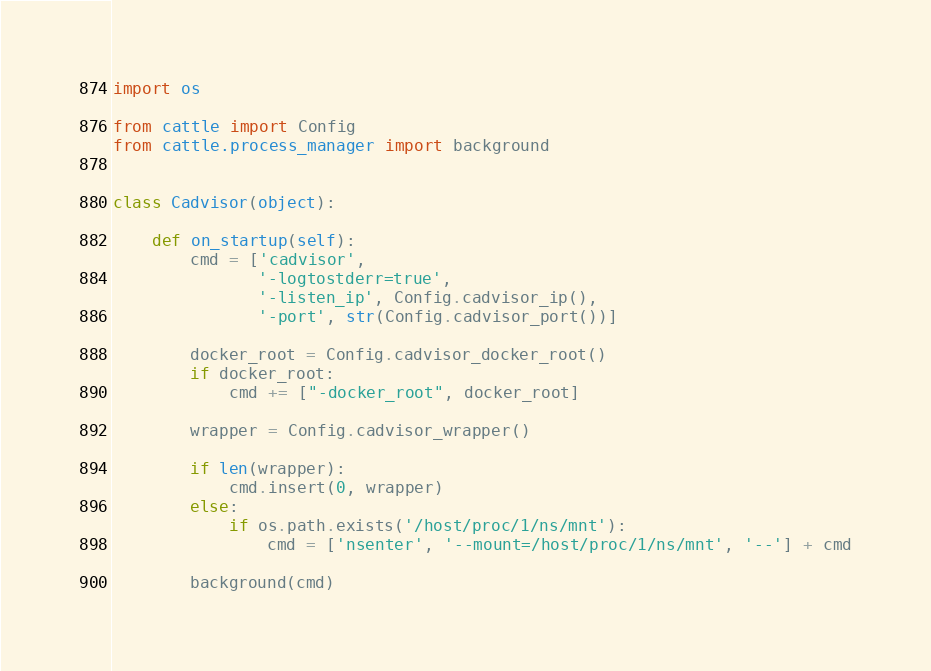Convert code to text. <code><loc_0><loc_0><loc_500><loc_500><_Python_>import os

from cattle import Config
from cattle.process_manager import background


class Cadvisor(object):

    def on_startup(self):
        cmd = ['cadvisor',
               '-logtostderr=true',
               '-listen_ip', Config.cadvisor_ip(),
               '-port', str(Config.cadvisor_port())]

        docker_root = Config.cadvisor_docker_root()
        if docker_root:
            cmd += ["-docker_root", docker_root]

        wrapper = Config.cadvisor_wrapper()

        if len(wrapper):
            cmd.insert(0, wrapper)
        else:
            if os.path.exists('/host/proc/1/ns/mnt'):
                cmd = ['nsenter', '--mount=/host/proc/1/ns/mnt', '--'] + cmd

        background(cmd)
</code> 